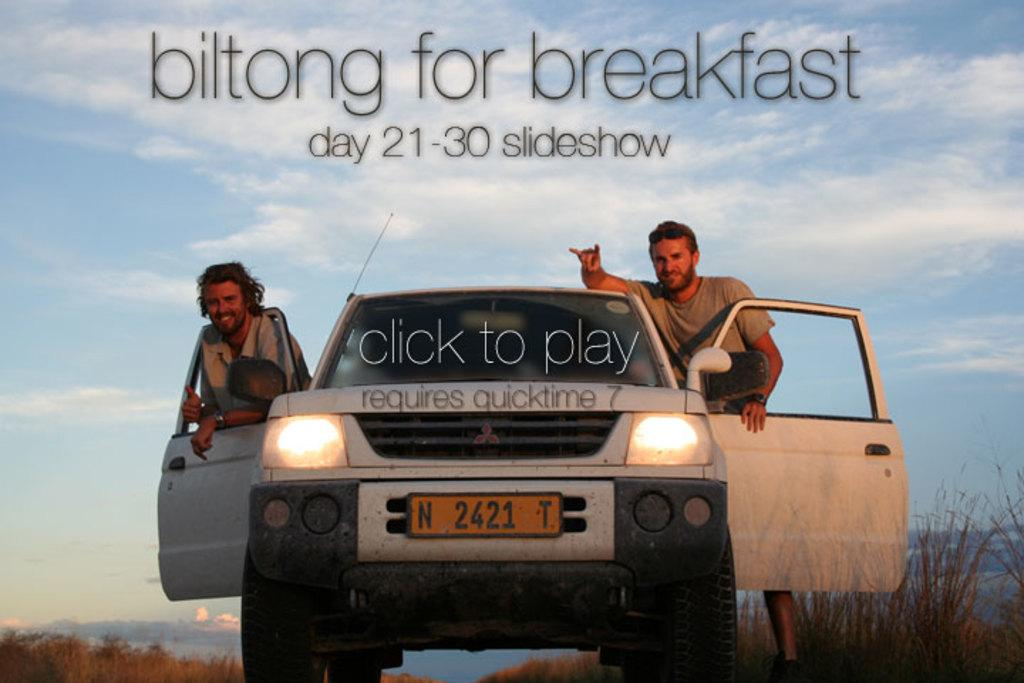What is the main subject of the image? The main subject of the image is a car. What can be seen on the car? The car has a number plate and lights. Who is present in the image? There are two men in the image, both smiling. What else can be seen in the image? There are plants and some text in the image. What is visible in the background of the image? The sky with clouds is visible in the background. What type of ornament is hanging from the rearview mirror of the car? There is no ornament hanging from the rearview mirror of the car in the image. Can you tell me how many baskets are visible in the image? There are no baskets visible in the image. 